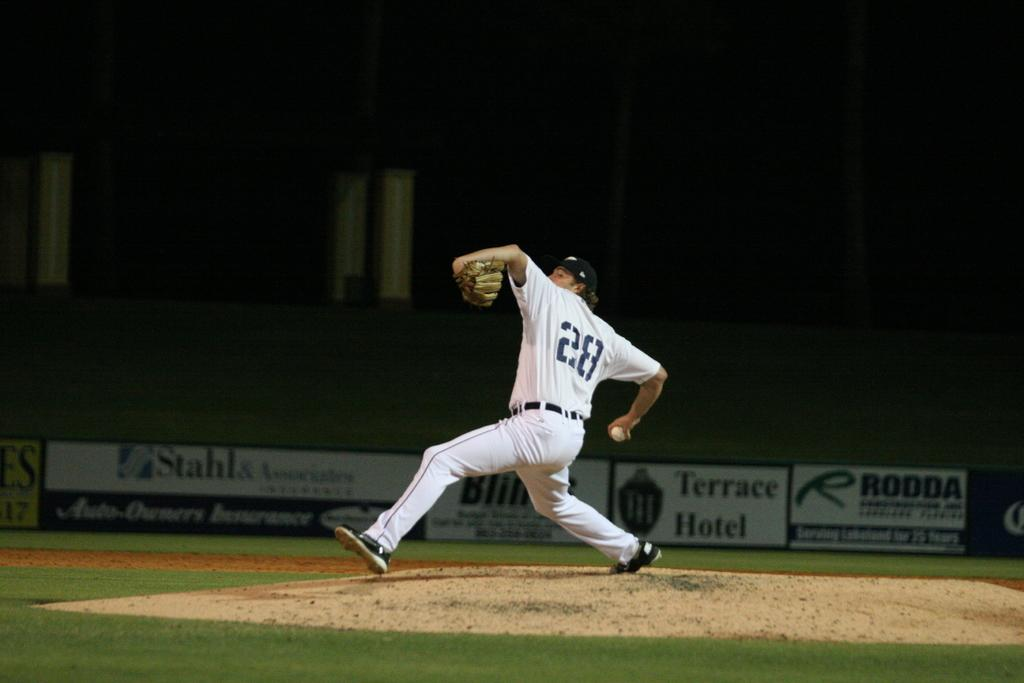<image>
Create a compact narrative representing the image presented. A baseball player throwing a pitch from the pitching mound and his jersey has a 28 on the back. 